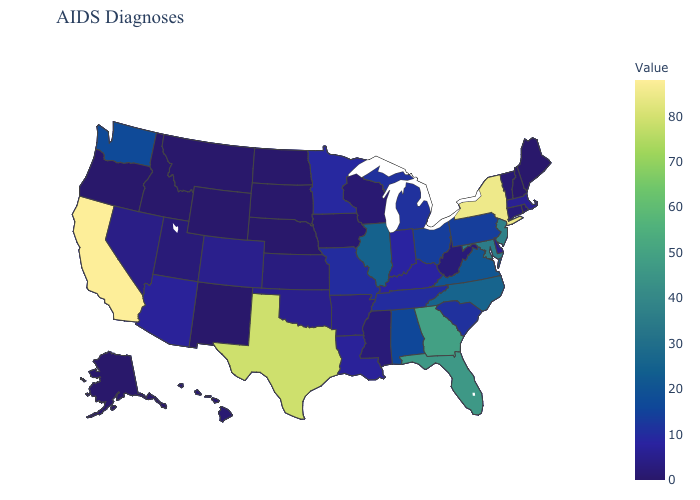Which states have the highest value in the USA?
Concise answer only. California. Which states hav the highest value in the Northeast?
Short answer required. New York. Which states hav the highest value in the West?
Give a very brief answer. California. Does Minnesota have the lowest value in the USA?
Concise answer only. No. Does New York have the highest value in the Northeast?
Keep it brief. Yes. Which states hav the highest value in the South?
Keep it brief. Texas. 